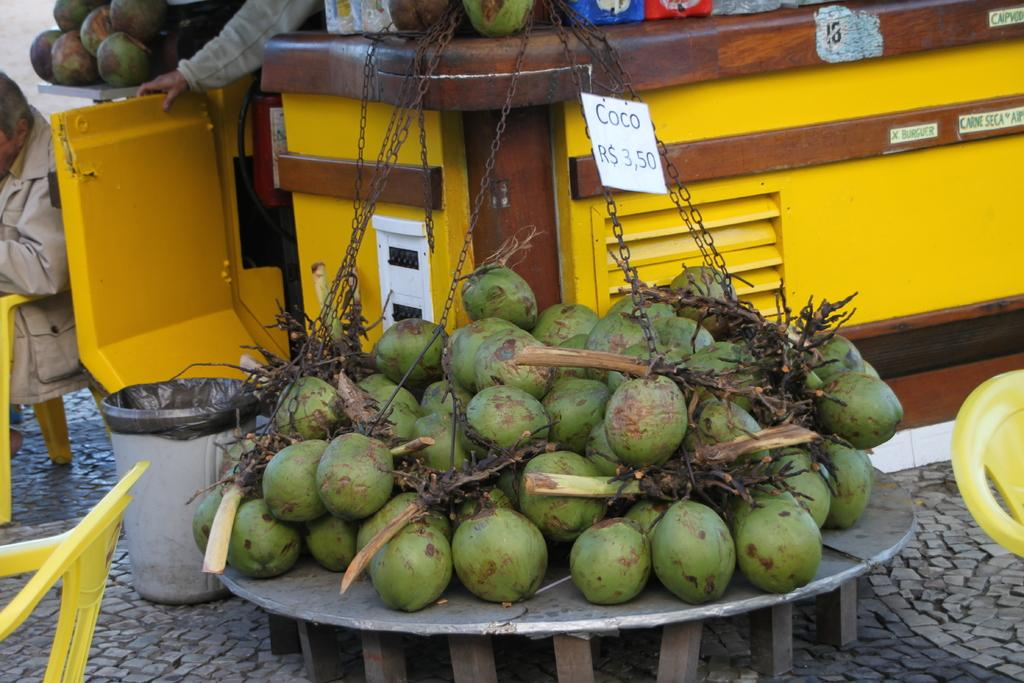What type of objects are present in the image? There are coconuts in the image. Are there any people in the image? Yes, there are persons in the image. What might be used for sitting in the image? There are empty chairs in the image. Where can waste be disposed of in the image? There is a dustbin in the image. What is located in the center of the image? There are objects in the center of the image. What type of interest can be seen on the faces of the persons in the image? There is no indication of interest on the faces of the persons in the image, as their expressions are not visible. 